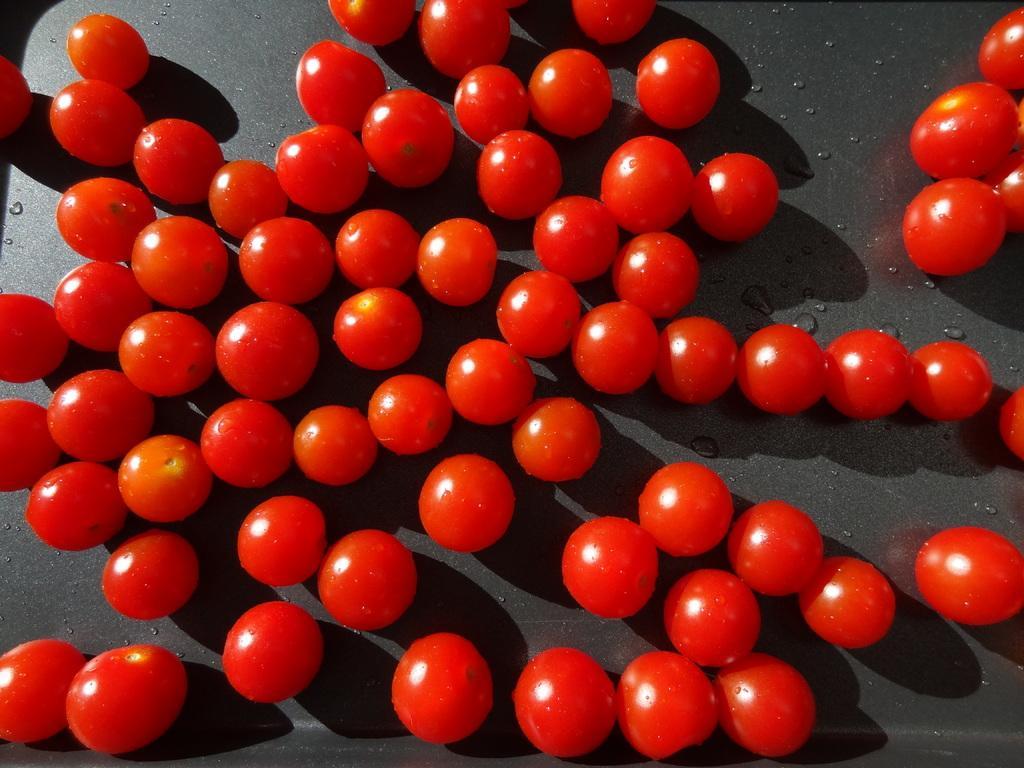Can you describe this image briefly? In this picture we can see a group of tomatoes and water drops on the black surface. 